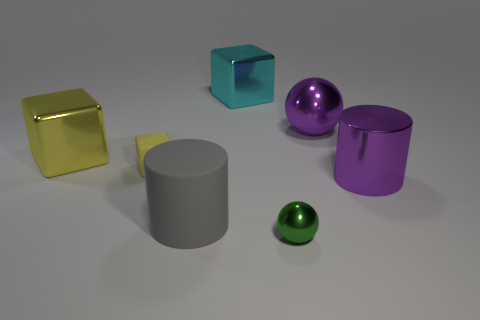Add 1 cyan things. How many objects exist? 8 Subtract all cylinders. How many objects are left? 5 Subtract all big red objects. Subtract all big cylinders. How many objects are left? 5 Add 2 big cyan things. How many big cyan things are left? 3 Add 2 large gray objects. How many large gray objects exist? 3 Subtract 0 yellow cylinders. How many objects are left? 7 